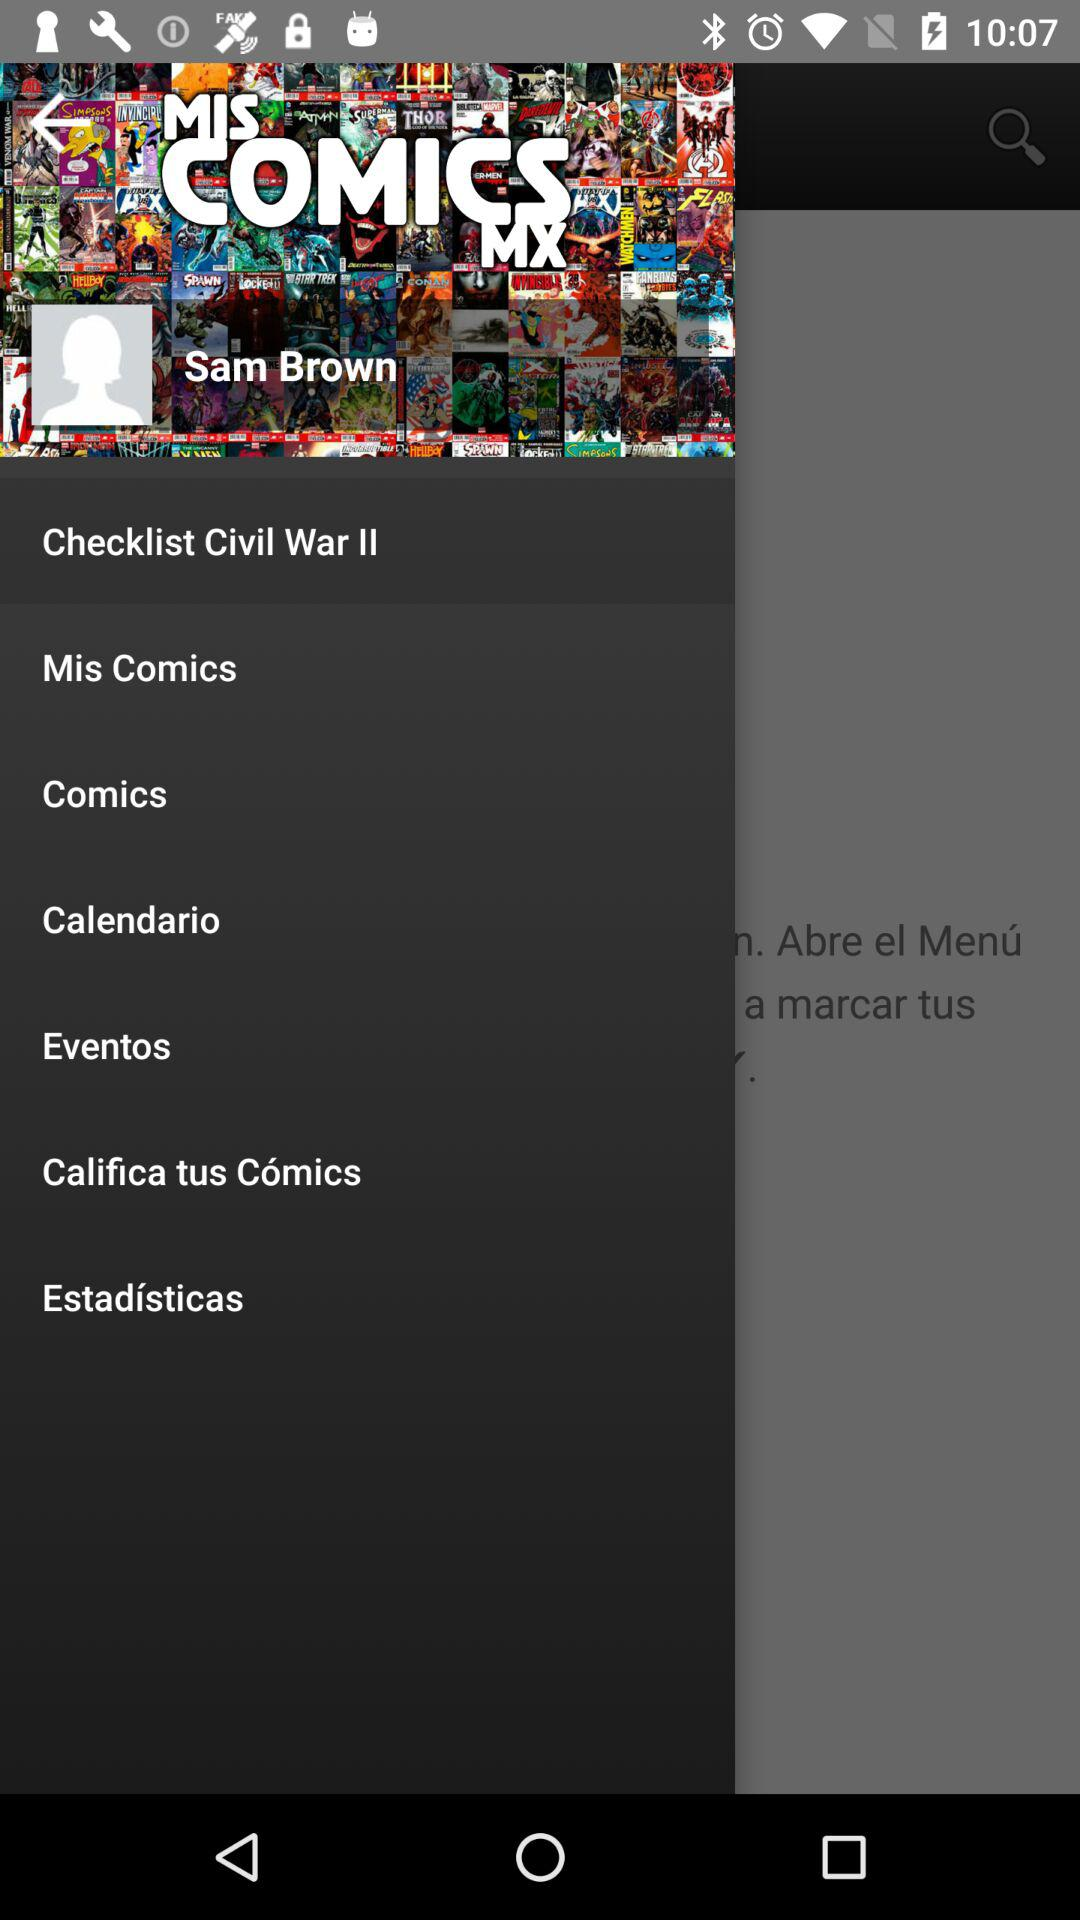What is the name of the user? The name of the user is Sam Brown. 